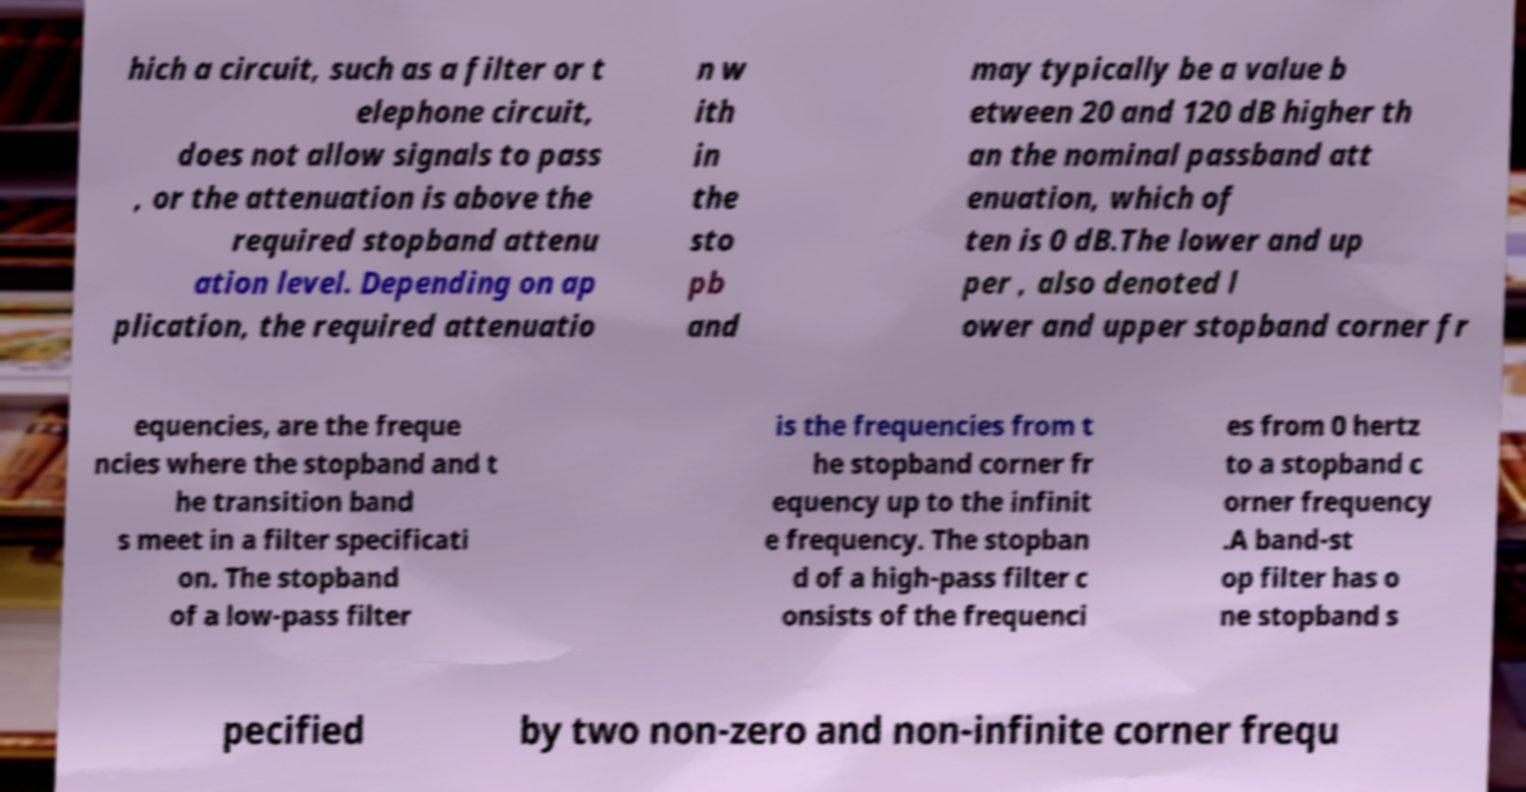Could you extract and type out the text from this image? hich a circuit, such as a filter or t elephone circuit, does not allow signals to pass , or the attenuation is above the required stopband attenu ation level. Depending on ap plication, the required attenuatio n w ith in the sto pb and may typically be a value b etween 20 and 120 dB higher th an the nominal passband att enuation, which of ten is 0 dB.The lower and up per , also denoted l ower and upper stopband corner fr equencies, are the freque ncies where the stopband and t he transition band s meet in a filter specificati on. The stopband of a low-pass filter is the frequencies from t he stopband corner fr equency up to the infinit e frequency. The stopban d of a high-pass filter c onsists of the frequenci es from 0 hertz to a stopband c orner frequency .A band-st op filter has o ne stopband s pecified by two non-zero and non-infinite corner frequ 